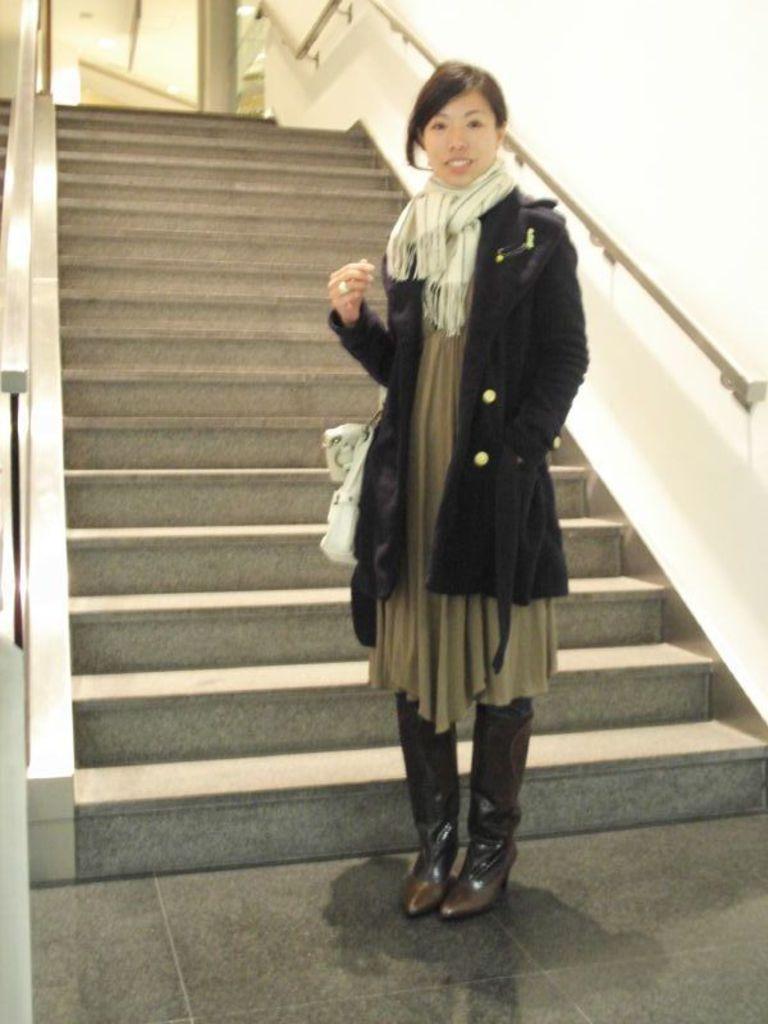Describe this image in one or two sentences. In this picture we can observe a woman standing, wearing a black color coat and white color scarf around her neck. She is smiling. Behind her there are stairs. On the right side there is a wall which is in white color. 